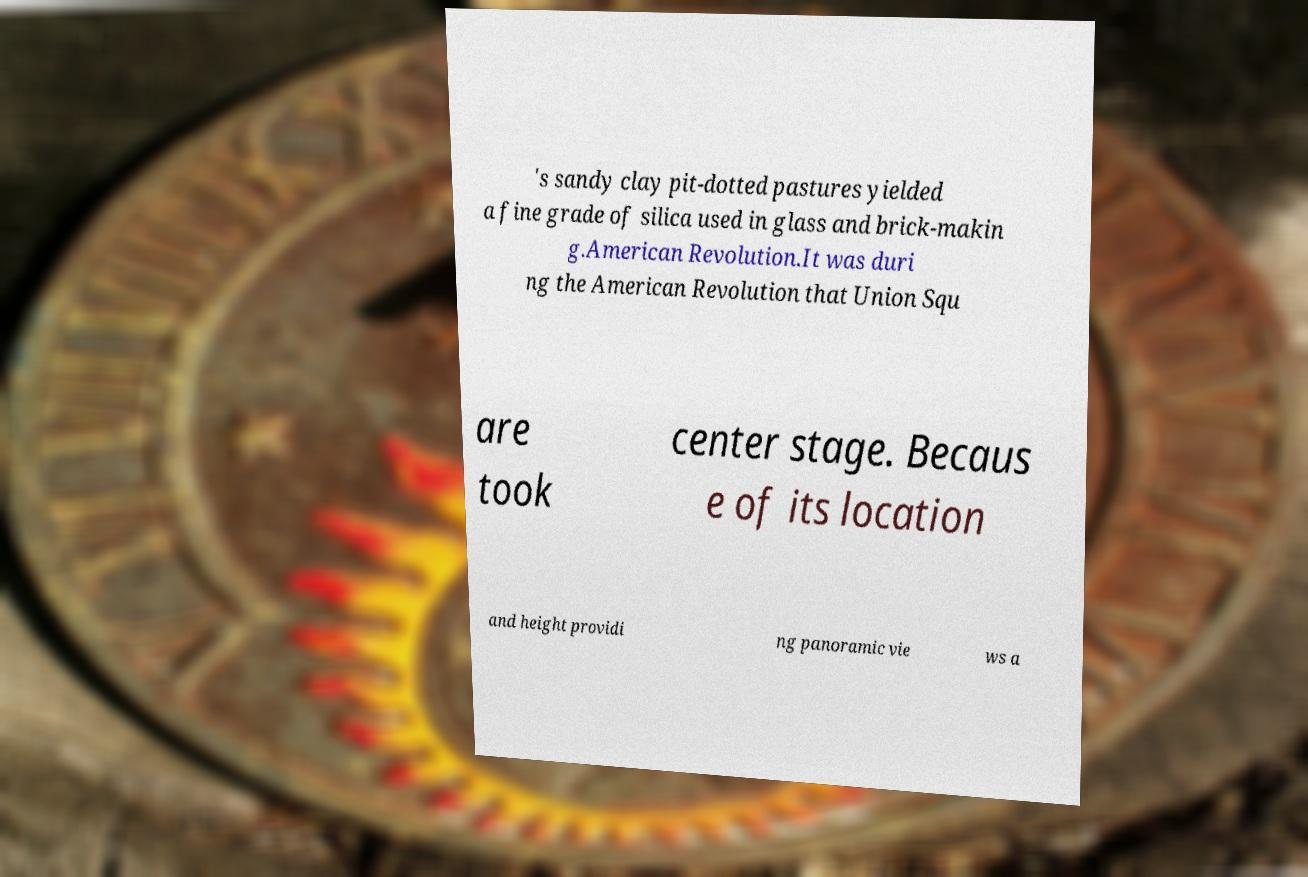Could you extract and type out the text from this image? 's sandy clay pit-dotted pastures yielded a fine grade of silica used in glass and brick-makin g.American Revolution.It was duri ng the American Revolution that Union Squ are took center stage. Becaus e of its location and height providi ng panoramic vie ws a 